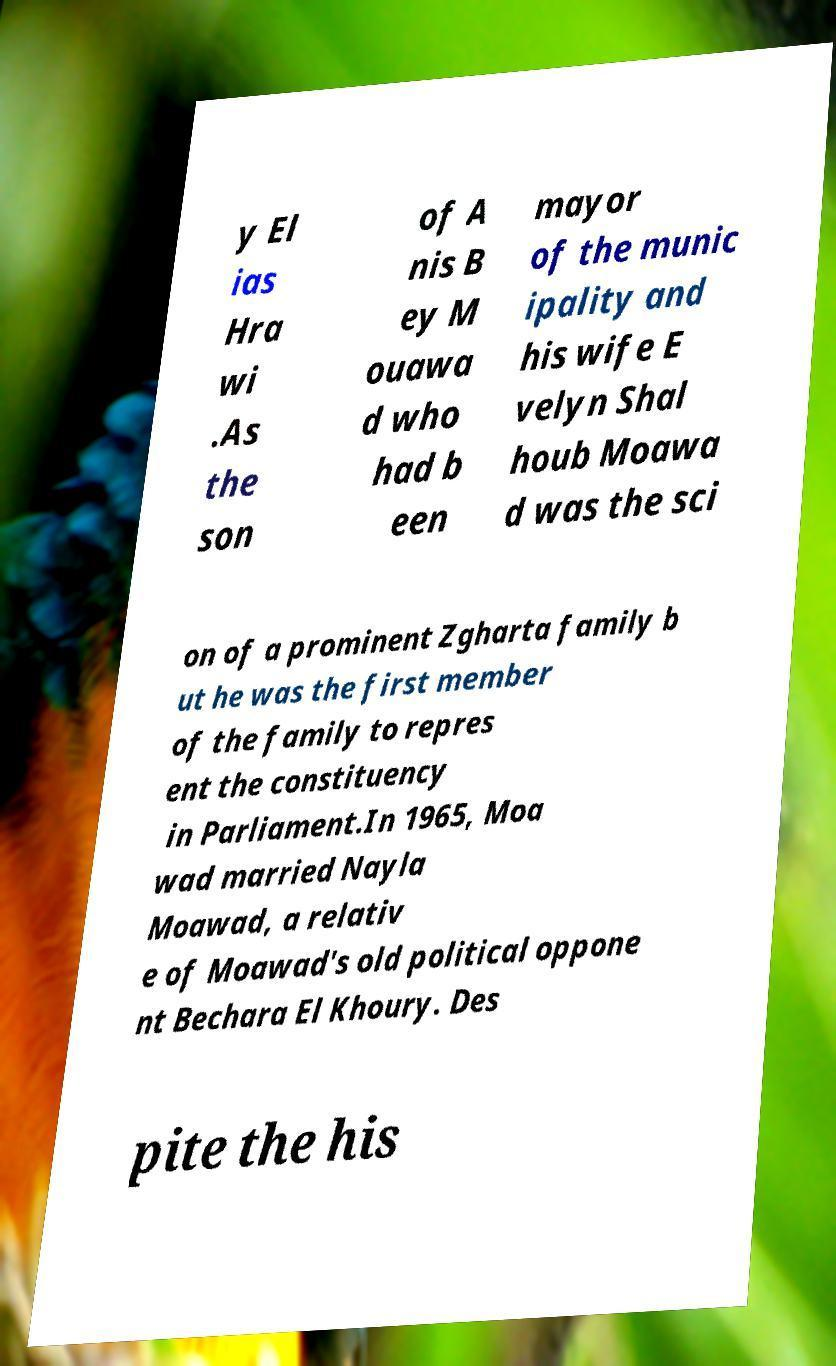I need the written content from this picture converted into text. Can you do that? y El ias Hra wi .As the son of A nis B ey M ouawa d who had b een mayor of the munic ipality and his wife E velyn Shal houb Moawa d was the sci on of a prominent Zgharta family b ut he was the first member of the family to repres ent the constituency in Parliament.In 1965, Moa wad married Nayla Moawad, a relativ e of Moawad's old political oppone nt Bechara El Khoury. Des pite the his 